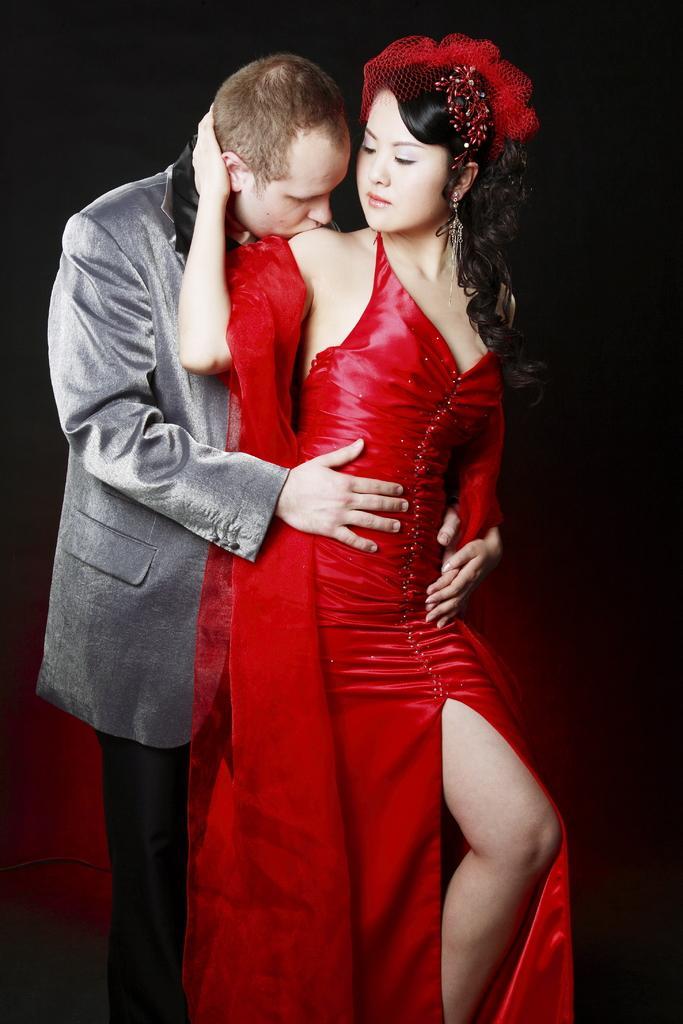How would you summarize this image in a sentence or two? In this image I see a man who is wearing suit and I see a woman who is wearing dress and I see that the man is kissing her on her shoulder and it is dark in the background. 